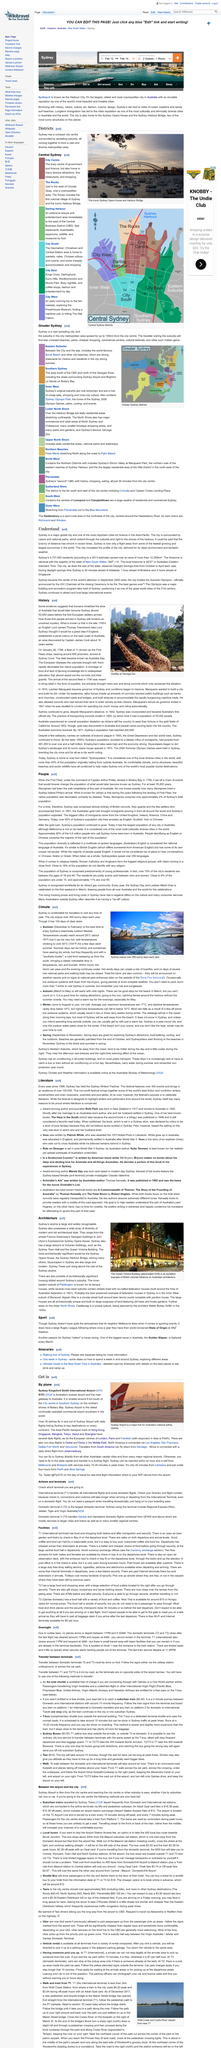List a handful of essential elements in this visual. Sydney is a major global city and one of the most significant cities for finance in the Asia-Pacific. The Sydney Writers' Festival was first held in 1998. The picture depicts giraffes at Taronga Zoo, and their identity is being questioned. The book 'The Harp in the South,' written by Ruth Park, was published in 1948. The photograph depicts the renowned Sydney Opera House and Harbour Bridge, which are prominently displayed in the image. 